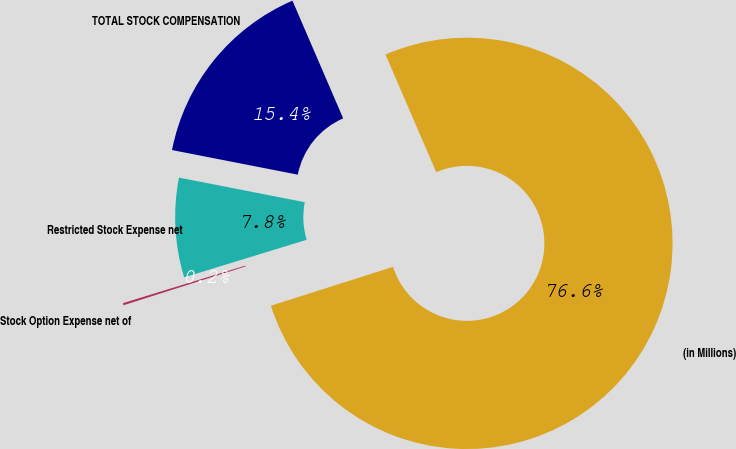<chart> <loc_0><loc_0><loc_500><loc_500><pie_chart><fcel>(in Millions)<fcel>Stock Option Expense net of<fcel>Restricted Stock Expense net<fcel>TOTAL STOCK COMPENSATION<nl><fcel>76.58%<fcel>0.17%<fcel>7.81%<fcel>15.45%<nl></chart> 